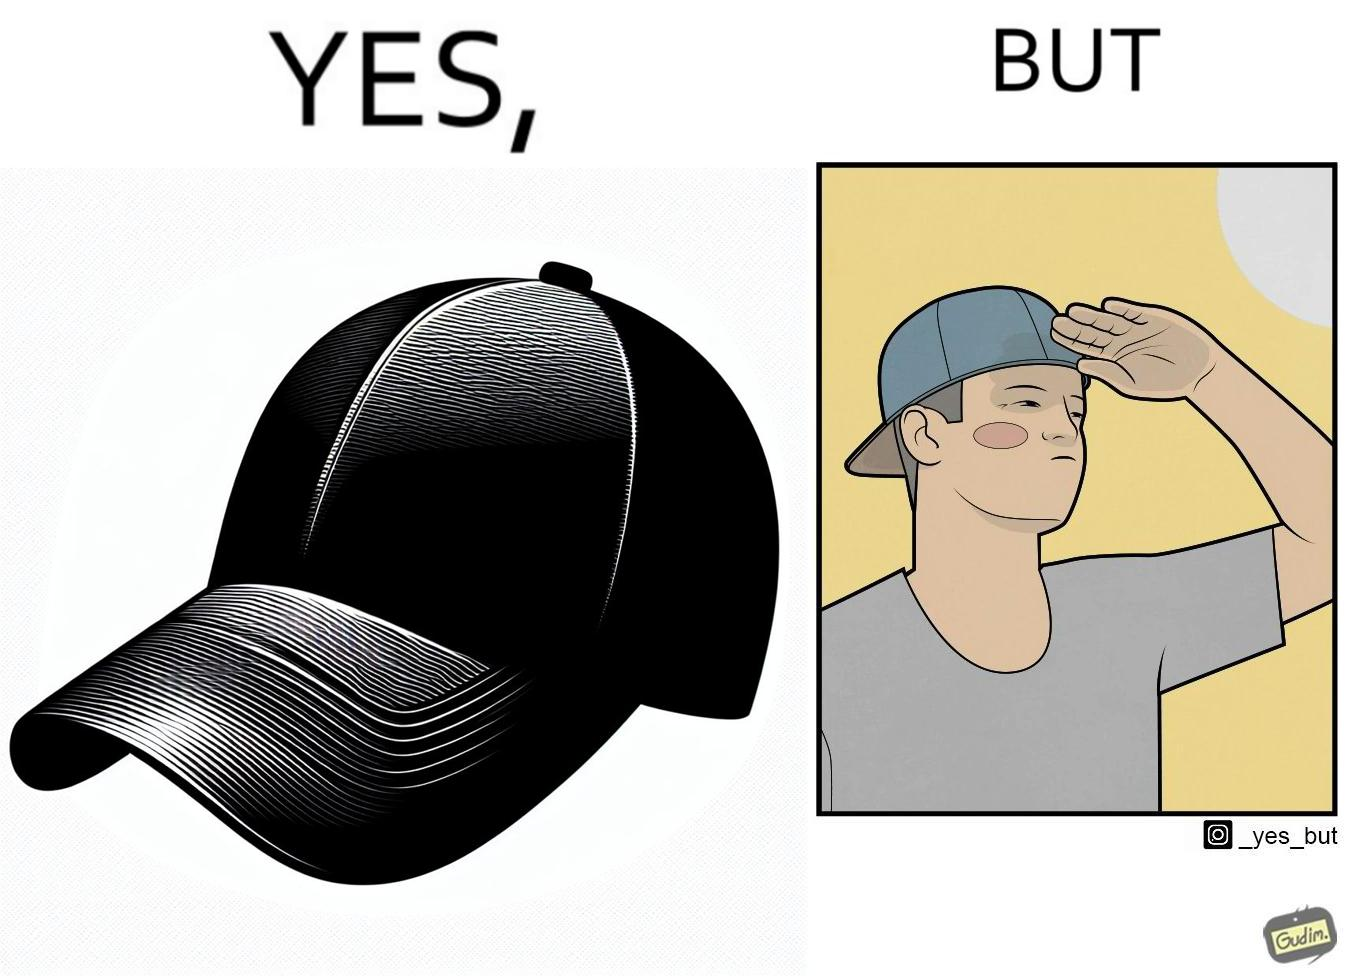Describe the satirical element in this image. This image is funny because a cap is MEANT to protect one's eyes from the sun, but this person is more interested in using it to look stylish, even if it makes them uncomfortable. 